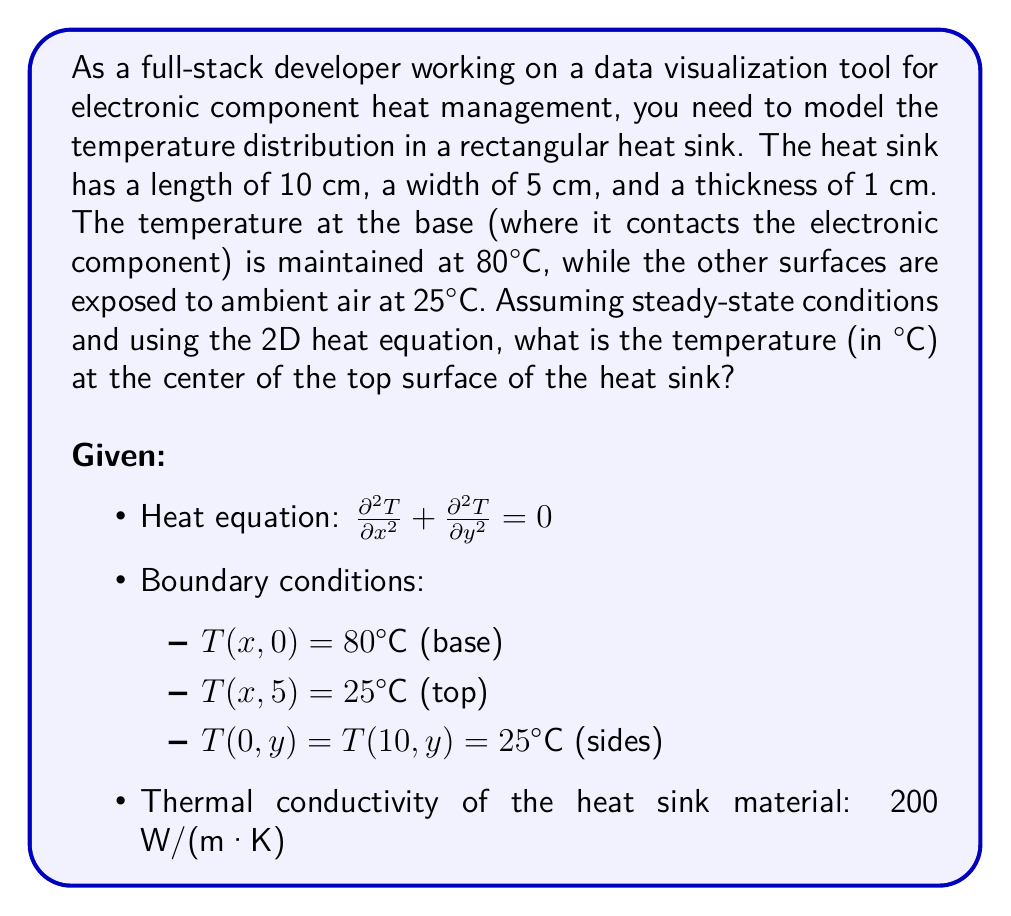Show me your answer to this math problem. To solve this problem, we'll use the method of separation of variables for the 2D heat equation:

1) Assume the solution has the form: $T(x,y) = X(x)Y(y)$

2) Substituting into the heat equation:
   $$X''(x)Y(y) + X(x)Y''(y) = 0$$
   $$\frac{X''(x)}{X(x)} = -\frac{Y''(y)}{Y(y)} = -\lambda^2$$

3) This leads to two ODEs:
   $$X''(x) + \lambda^2 X(x) = 0$$
   $$Y''(y) - \lambda^2 Y(y) = 0$$

4) The general solutions are:
   $$X(x) = A \cos(\lambda x) + B \sin(\lambda x)$$
   $$Y(y) = C e^{\lambda y} + D e^{-\lambda y}$$

5) Applying the boundary conditions:
   - $T(0,y) = T(10,y) = 25°C$ implies $\lambda_n = \frac{n\pi}{10}$ where $n$ is odd
   - $T(x,0) = 80°C$ and $T(x,5) = 25°C$

6) The solution that satisfies all boundary conditions is:
   $$T(x,y) = 25 + \sum_{n=1,3,5,...}^{\infty} A_n \sin(\frac{n\pi x}{10}) \sinh(\frac{n\pi (5-y)}{10}) / \sinh(\frac{5n\pi}{10})$$

7) Where $A_n = \frac{110}{\pi n} \int_0^{10} \sin(\frac{n\pi x}{10}) dx = \frac{440}{n\pi}$ for odd $n$

8) To find the temperature at the center of the top surface, we need to evaluate $T(5,5)$:
   $$T(5,5) = 25 + \sum_{n=1,3,5,...}^{\infty} \frac{440}{n\pi} \sin(\frac{n\pi}{2}) \cdot 0$$

9) Since $\sinh(0) = 0$, all terms in the sum become zero.

Therefore, the temperature at the center of the top surface is 25°C.
Answer: 25°C 